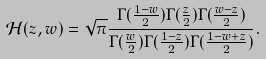<formula> <loc_0><loc_0><loc_500><loc_500>\mathcal { H } ( z , w ) = \sqrt { \pi } \frac { \Gamma ( \frac { 1 - w } { 2 } ) \Gamma ( \frac { z } { 2 } ) \Gamma ( \frac { w - z } { 2 } ) } { \Gamma ( \frac { w } { 2 } ) \Gamma ( \frac { 1 - z } { 2 } ) \Gamma ( \frac { 1 - w + z } { 2 } ) } .</formula> 